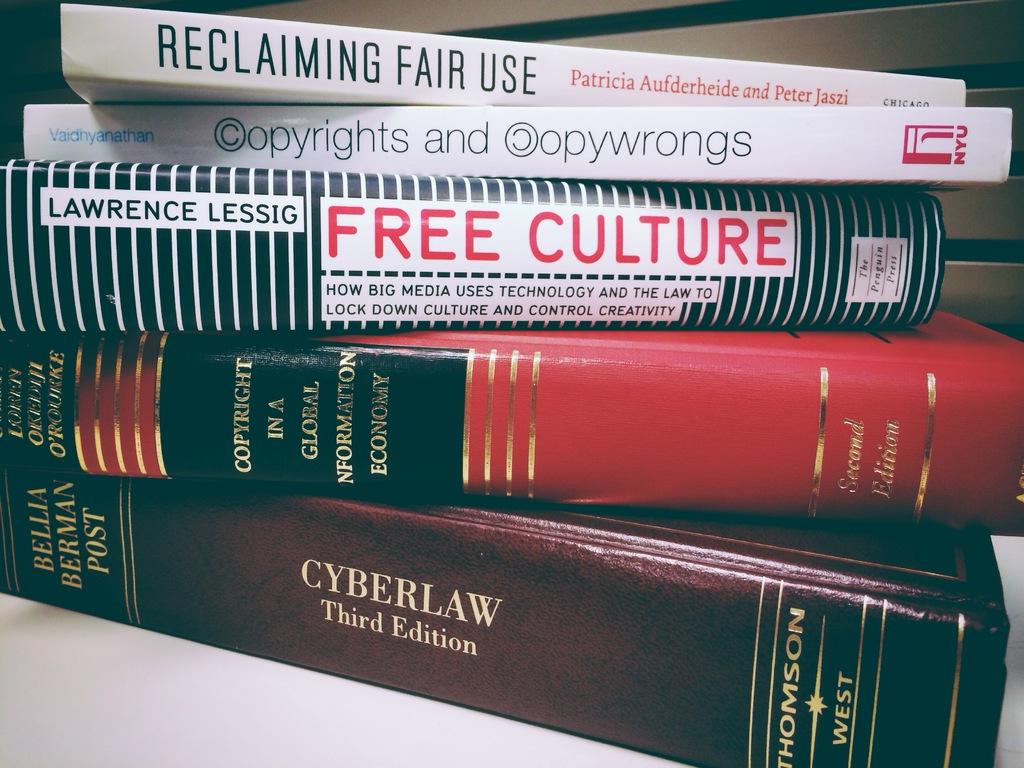What is the title of the book on top of the pile?
Give a very brief answer. Reclaiming fair use. What is edition of the cyberlaw?
Offer a very short reply. Third. 